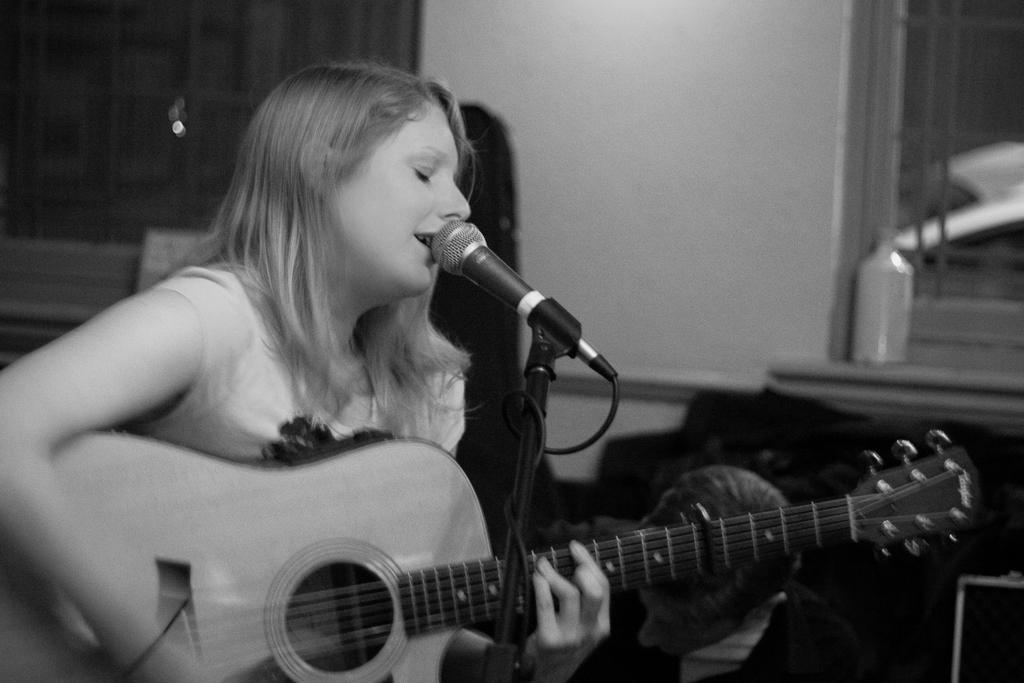Could you give a brief overview of what you see in this image? A girl is singing with a mic and playing a guitar. 